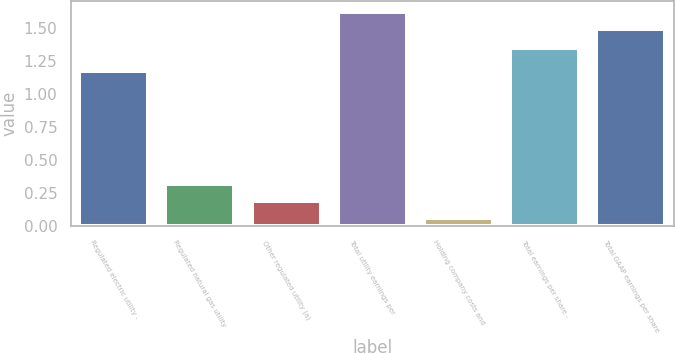Convert chart. <chart><loc_0><loc_0><loc_500><loc_500><bar_chart><fcel>Regulated electric utility -<fcel>Regulated natural gas utility<fcel>Other regulated utility (a)<fcel>Total utility earnings per<fcel>Holding company costs and<fcel>Total earnings per share -<fcel>Total GAAP earnings per share<nl><fcel>1.17<fcel>0.32<fcel>0.19<fcel>1.62<fcel>0.06<fcel>1.35<fcel>1.49<nl></chart> 